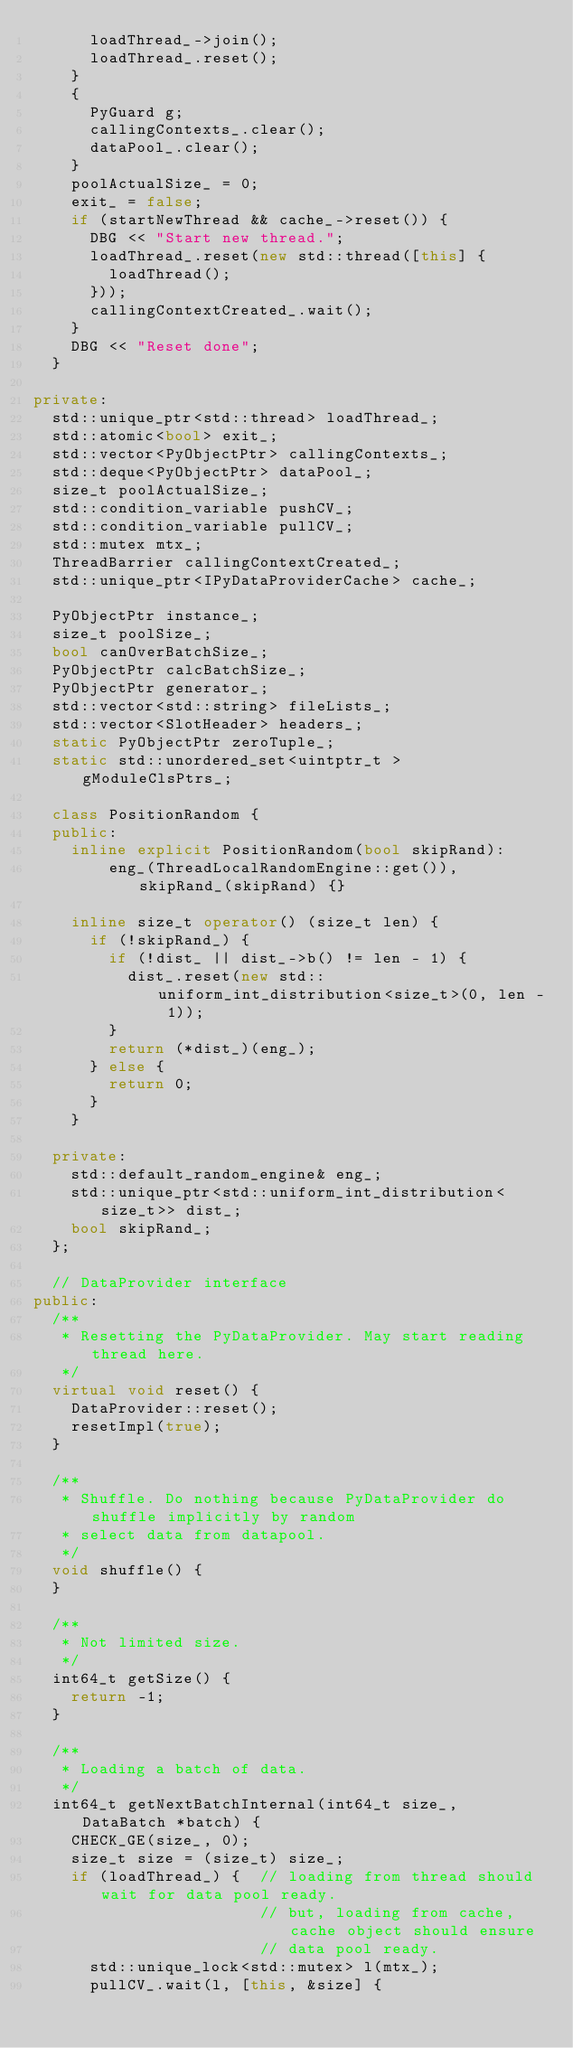<code> <loc_0><loc_0><loc_500><loc_500><_C++_>      loadThread_->join();
      loadThread_.reset();
    }
    {
      PyGuard g;
      callingContexts_.clear();
      dataPool_.clear();
    }
    poolActualSize_ = 0;
    exit_ = false;
    if (startNewThread && cache_->reset()) {
      DBG << "Start new thread.";
      loadThread_.reset(new std::thread([this] {
        loadThread();
      }));
      callingContextCreated_.wait();
    }
    DBG << "Reset done";
  }

private:
  std::unique_ptr<std::thread> loadThread_;
  std::atomic<bool> exit_;
  std::vector<PyObjectPtr> callingContexts_;
  std::deque<PyObjectPtr> dataPool_;
  size_t poolActualSize_;
  std::condition_variable pushCV_;
  std::condition_variable pullCV_;
  std::mutex mtx_;
  ThreadBarrier callingContextCreated_;
  std::unique_ptr<IPyDataProviderCache> cache_;

  PyObjectPtr instance_;
  size_t poolSize_;
  bool canOverBatchSize_;
  PyObjectPtr calcBatchSize_;
  PyObjectPtr generator_;
  std::vector<std::string> fileLists_;
  std::vector<SlotHeader> headers_;
  static PyObjectPtr zeroTuple_;
  static std::unordered_set<uintptr_t > gModuleClsPtrs_;

  class PositionRandom {
  public:
    inline explicit PositionRandom(bool skipRand):
        eng_(ThreadLocalRandomEngine::get()), skipRand_(skipRand) {}

    inline size_t operator() (size_t len) {
      if (!skipRand_) {
        if (!dist_ || dist_->b() != len - 1) {
          dist_.reset(new std::uniform_int_distribution<size_t>(0, len - 1));
        }
        return (*dist_)(eng_);
      } else {
        return 0;
      }
    }

  private:
    std::default_random_engine& eng_;
    std::unique_ptr<std::uniform_int_distribution<size_t>> dist_;
    bool skipRand_;
  };

  // DataProvider interface
public:
  /**
   * Resetting the PyDataProvider. May start reading thread here.
   */
  virtual void reset() {
    DataProvider::reset();
    resetImpl(true);
  }

  /**
   * Shuffle. Do nothing because PyDataProvider do shuffle implicitly by random
   * select data from datapool.
   */
  void shuffle() {
  }

  /**
   * Not limited size.
   */
  int64_t getSize() {
    return -1;
  }

  /**
   * Loading a batch of data.
   */
  int64_t getNextBatchInternal(int64_t size_, DataBatch *batch) {
    CHECK_GE(size_, 0);
    size_t size = (size_t) size_;
    if (loadThread_) {  // loading from thread should wait for data pool ready.
                        // but, loading from cache, cache object should ensure
                        // data pool ready.
      std::unique_lock<std::mutex> l(mtx_);
      pullCV_.wait(l, [this, &size] {</code> 